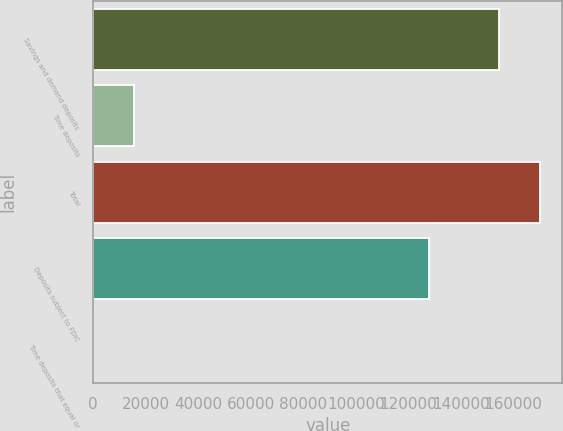Convert chart to OTSL. <chart><loc_0><loc_0><loc_500><loc_500><bar_chart><fcel>Savings and demand deposits<fcel>Time deposits<fcel>Total<fcel>Deposits subject to FDIC<fcel>Time deposits that equal or<nl><fcel>154559<fcel>15627.7<fcel>170141<fcel>127992<fcel>46<nl></chart> 